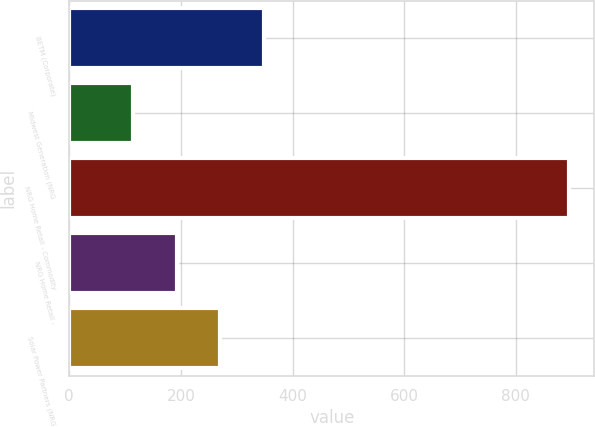Convert chart to OTSL. <chart><loc_0><loc_0><loc_500><loc_500><bar_chart><fcel>BETM (Corporate)<fcel>Midwest Generation (NRG<fcel>NRG Home Retail - Commodity<fcel>NRG Home Retail -<fcel>Solar Power Partners (NRG<nl><fcel>348.6<fcel>114<fcel>896<fcel>192.2<fcel>270.4<nl></chart> 